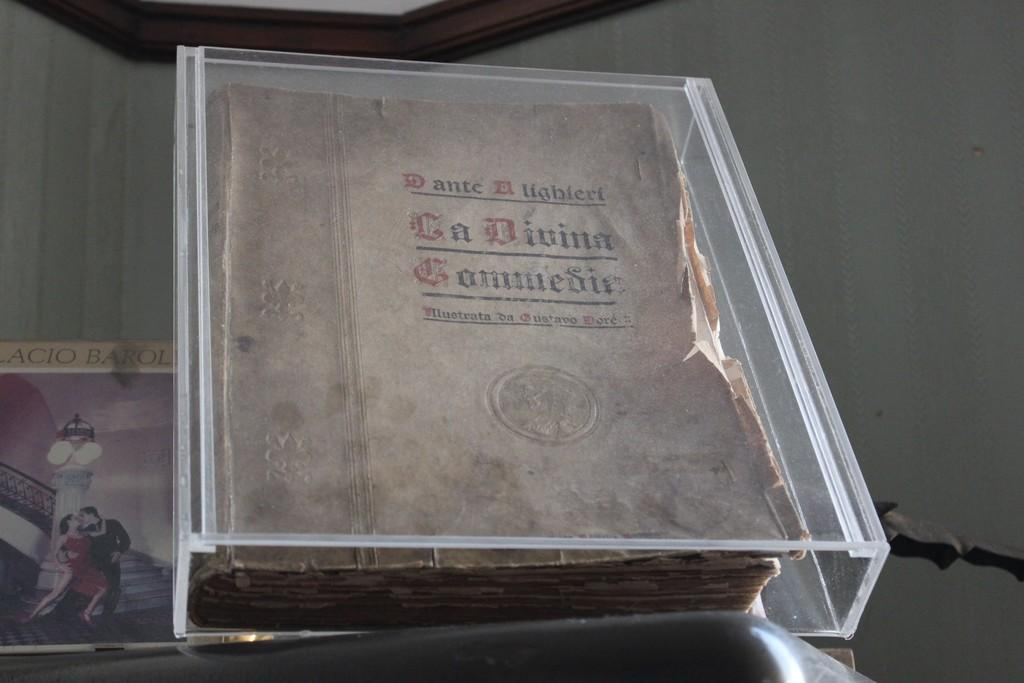What is placed on the glass box in the image? There is a book on a glass box in the image. What is placed on the table in the image? There is another book on a table in the image. What can be seen in the background of the image? There are walls visible in the background of the image. What type of badge is attached to the book on the table? There is no badge present on the book or any other item in the image. What is the yoke used for in the image? There is no yoke present in the image. 